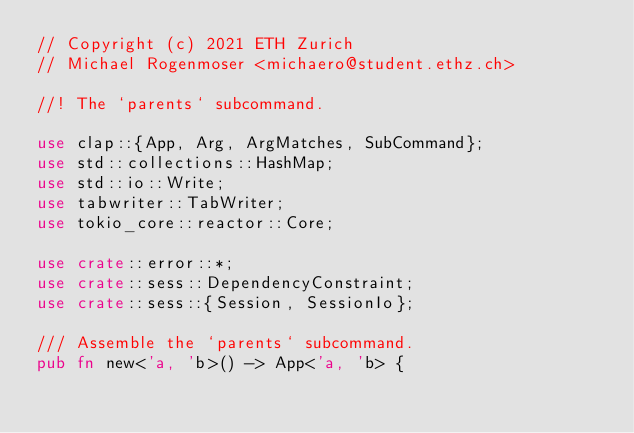Convert code to text. <code><loc_0><loc_0><loc_500><loc_500><_Rust_>// Copyright (c) 2021 ETH Zurich
// Michael Rogenmoser <michaero@student.ethz.ch>

//! The `parents` subcommand.

use clap::{App, Arg, ArgMatches, SubCommand};
use std::collections::HashMap;
use std::io::Write;
use tabwriter::TabWriter;
use tokio_core::reactor::Core;

use crate::error::*;
use crate::sess::DependencyConstraint;
use crate::sess::{Session, SessionIo};

/// Assemble the `parents` subcommand.
pub fn new<'a, 'b>() -> App<'a, 'b> {</code> 